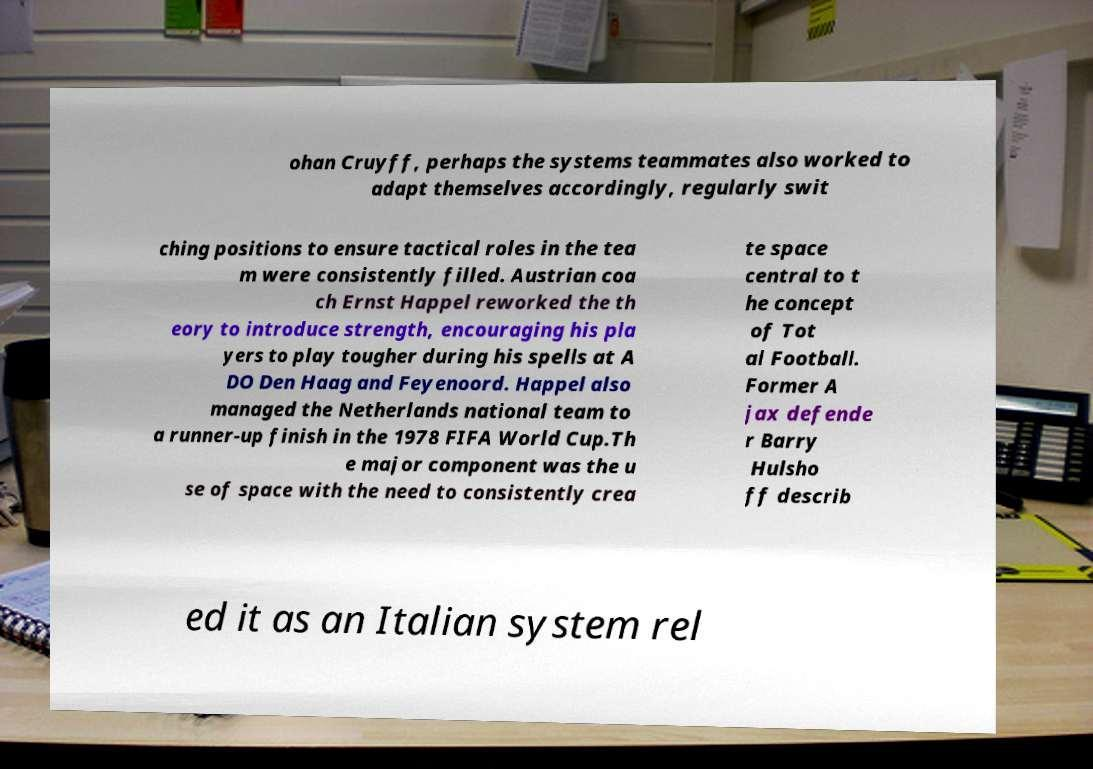There's text embedded in this image that I need extracted. Can you transcribe it verbatim? ohan Cruyff, perhaps the systems teammates also worked to adapt themselves accordingly, regularly swit ching positions to ensure tactical roles in the tea m were consistently filled. Austrian coa ch Ernst Happel reworked the th eory to introduce strength, encouraging his pla yers to play tougher during his spells at A DO Den Haag and Feyenoord. Happel also managed the Netherlands national team to a runner-up finish in the 1978 FIFA World Cup.Th e major component was the u se of space with the need to consistently crea te space central to t he concept of Tot al Football. Former A jax defende r Barry Hulsho ff describ ed it as an Italian system rel 